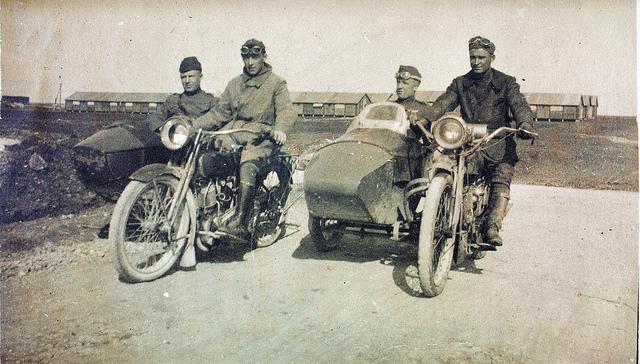Is this a current photo?
Keep it brief. No. What are the men riding?
Quick response, please. Motorcycles. Is the photo black and white?
Concise answer only. Yes. 